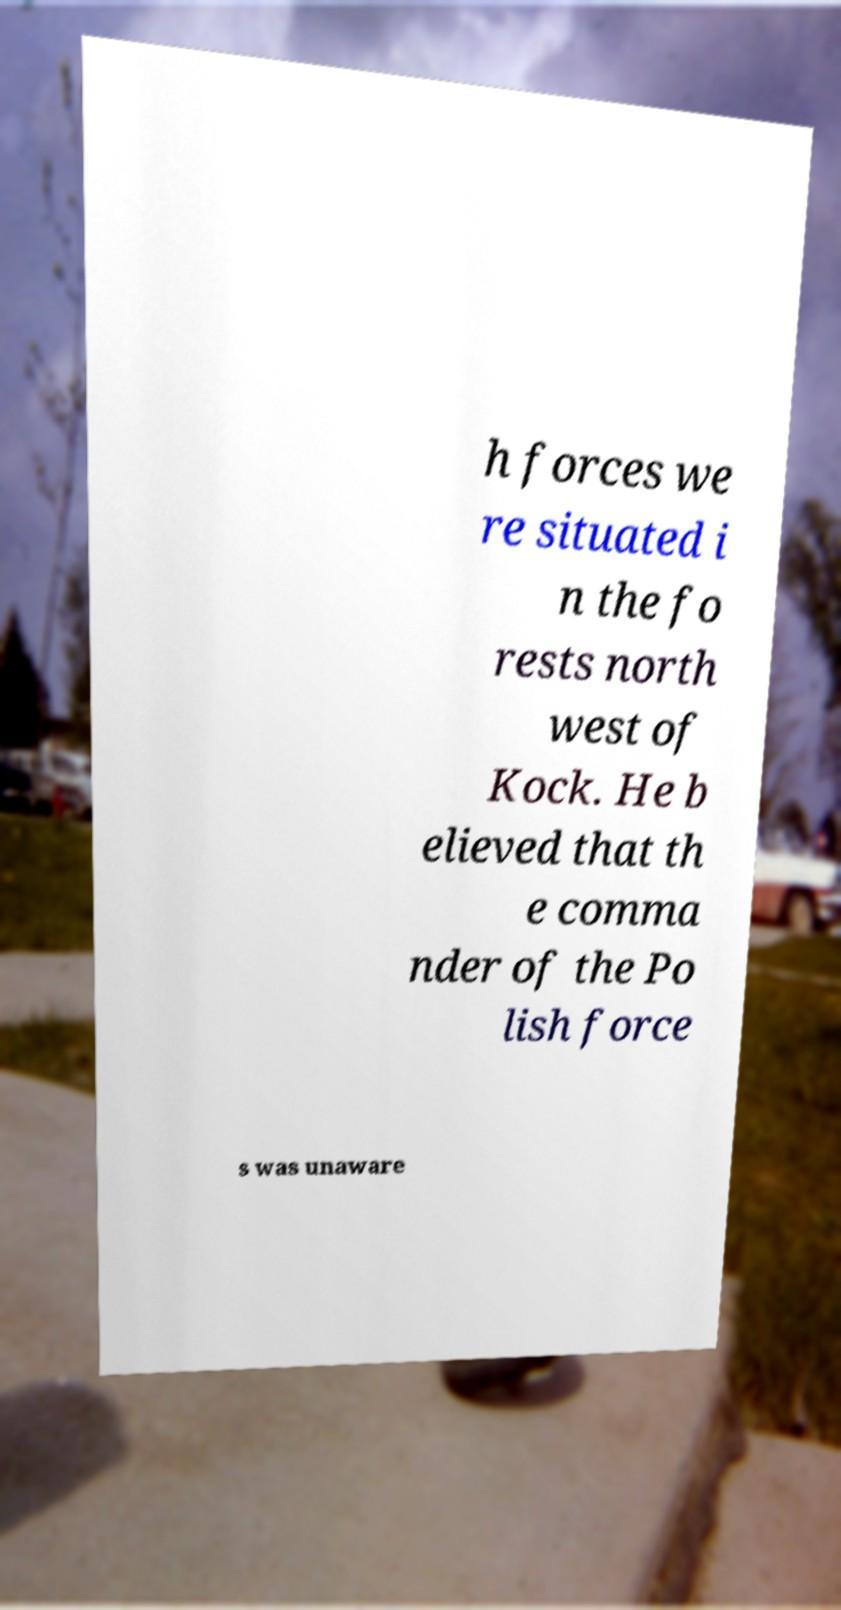What messages or text are displayed in this image? I need them in a readable, typed format. h forces we re situated i n the fo rests north west of Kock. He b elieved that th e comma nder of the Po lish force s was unaware 